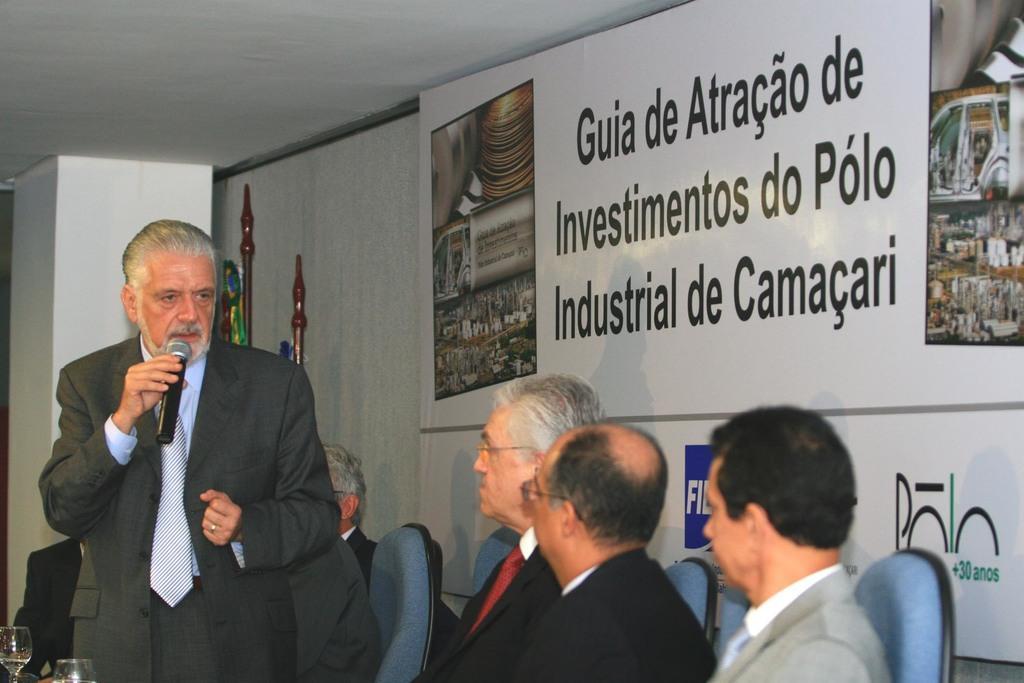In one or two sentences, can you explain what this image depicts? At the bottom of the image we can see some persons are sitting on the chairs. In the bottom left corner we can see the glasses. On the left side of the image we can see a man is standing and holding a mic. In the background of the image we can see the boards, wall, sticks, pillar. At the top of the image we can see the roof. 